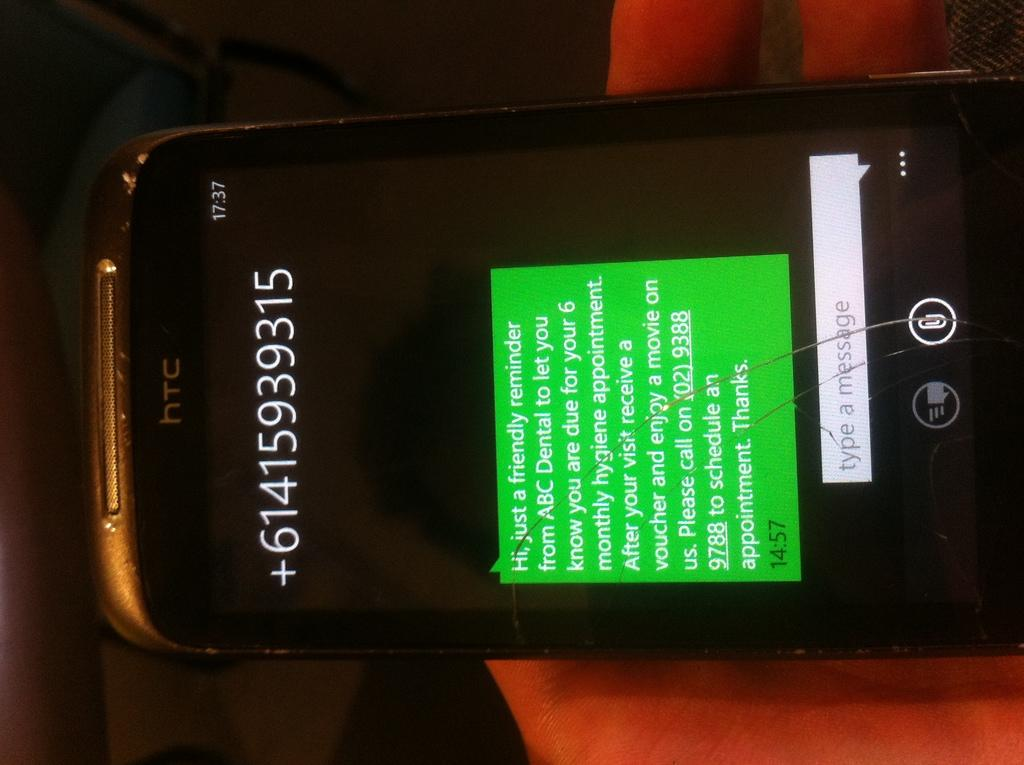<image>
Share a concise interpretation of the image provided. An HTC phone with the number +61415939315 displayed. 